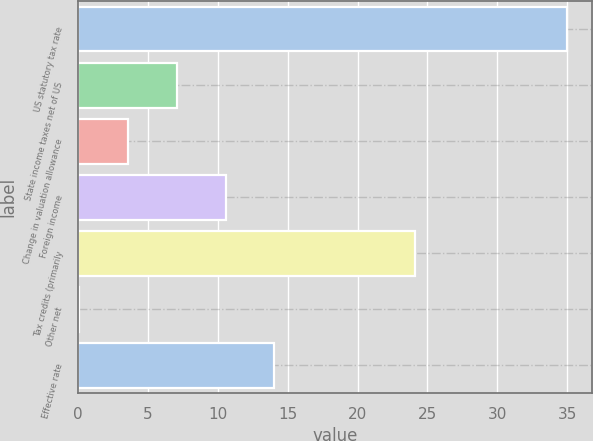Convert chart. <chart><loc_0><loc_0><loc_500><loc_500><bar_chart><fcel>US statutory tax rate<fcel>State income taxes net of US<fcel>Change in valuation allowance<fcel>Foreign income<fcel>Tax credits (primarily<fcel>Other net<fcel>Effective rate<nl><fcel>35<fcel>7.08<fcel>3.59<fcel>10.57<fcel>24.1<fcel>0.1<fcel>14.06<nl></chart> 